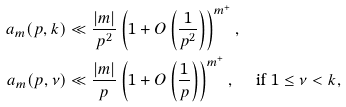<formula> <loc_0><loc_0><loc_500><loc_500>a _ { m } ( p , k ) & \ll \frac { | m | } { p ^ { 2 } } \left ( 1 + O \left ( \frac { 1 } { p ^ { 2 } } \right ) \right ) ^ { m ^ { + } } , \\ a _ { m } ( p , \nu ) & \ll \frac { | m | } { p } \left ( 1 + O \left ( \frac { 1 } { p } \right ) \right ) ^ { m ^ { + } } , \quad \text {  if } 1 \leq \nu < k ,</formula> 